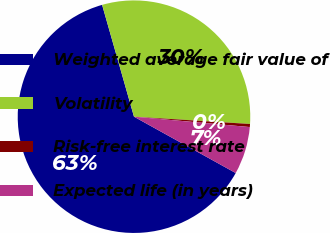Convert chart to OTSL. <chart><loc_0><loc_0><loc_500><loc_500><pie_chart><fcel>Weighted average fair value of<fcel>Volatility<fcel>Risk-free interest rate<fcel>Expected life (in years)<nl><fcel>62.52%<fcel>30.42%<fcel>0.42%<fcel>6.63%<nl></chart> 